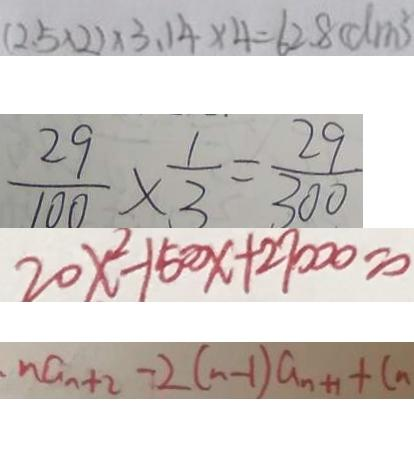Convert formula to latex. <formula><loc_0><loc_0><loc_500><loc_500>( 2 . 5 \times 2 ) \times 3 . 1 4 \times 4 = 6 2 . 8 ( d m ^ { 2 } ) 
 \frac { 2 9 } { 1 0 0 } \times \frac { 1 } { 3 } = \frac { 2 9 } { 3 0 0 } 
 2 0 x ^ { 2 } - 1 5 0 0 x + 2 7 0 0 0 = 0 
 n a _ { n + 2 } - 2 ( n - 1 ) a _ { n + 1 } + C n</formula> 